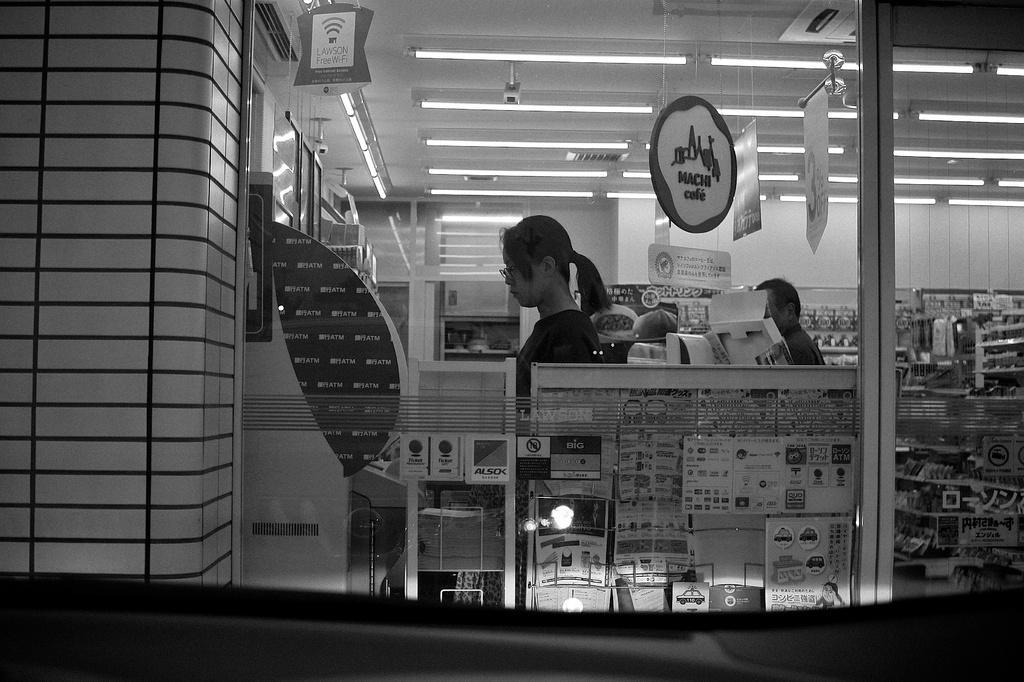Please provide a concise description of this image. In the foreground of this picture we can see some objects and we can see the text on the posters. On the left we can see the two people seems to be standing on the ground and we can see the cabinets containing many number of objects. At the top there is a roof and the lights and we can see the cameras. In the background we can see the wall and we can see the glass objects and we can see many other objects in the background. 